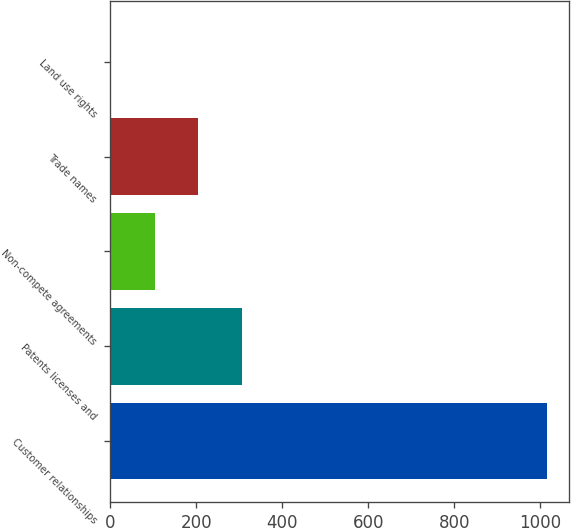Convert chart. <chart><loc_0><loc_0><loc_500><loc_500><bar_chart><fcel>Customer relationships<fcel>Patents licenses and<fcel>Non-compete agreements<fcel>Trade names<fcel>Land use rights<nl><fcel>1014.9<fcel>306.29<fcel>103.83<fcel>205.06<fcel>2.6<nl></chart> 